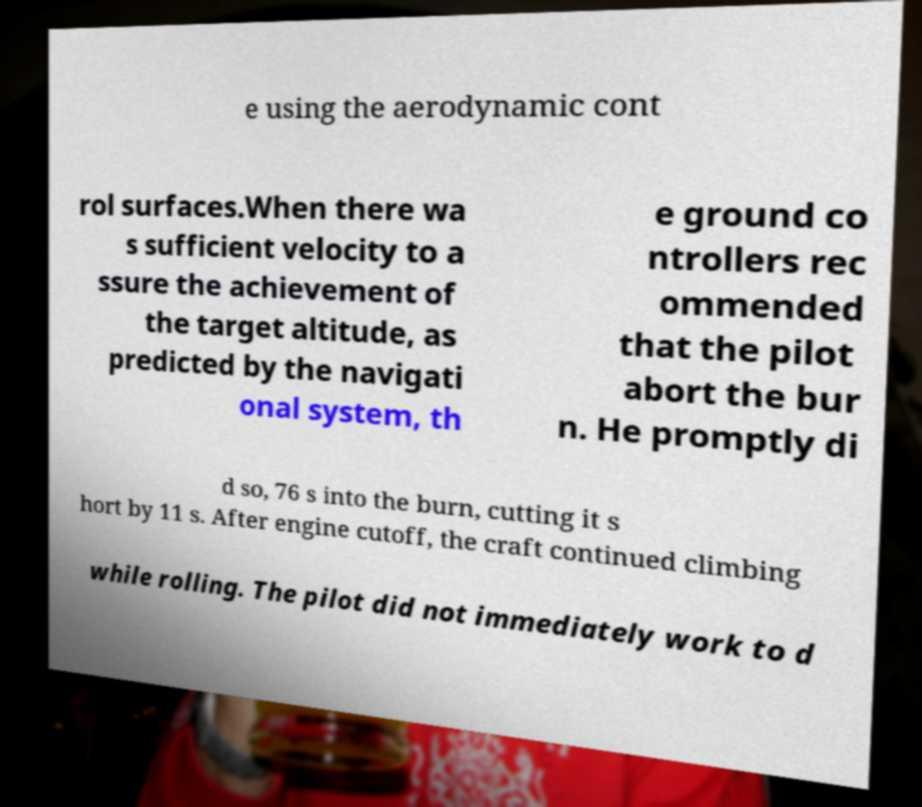There's text embedded in this image that I need extracted. Can you transcribe it verbatim? e using the aerodynamic cont rol surfaces.When there wa s sufficient velocity to a ssure the achievement of the target altitude, as predicted by the navigati onal system, th e ground co ntrollers rec ommended that the pilot abort the bur n. He promptly di d so, 76 s into the burn, cutting it s hort by 11 s. After engine cutoff, the craft continued climbing while rolling. The pilot did not immediately work to d 